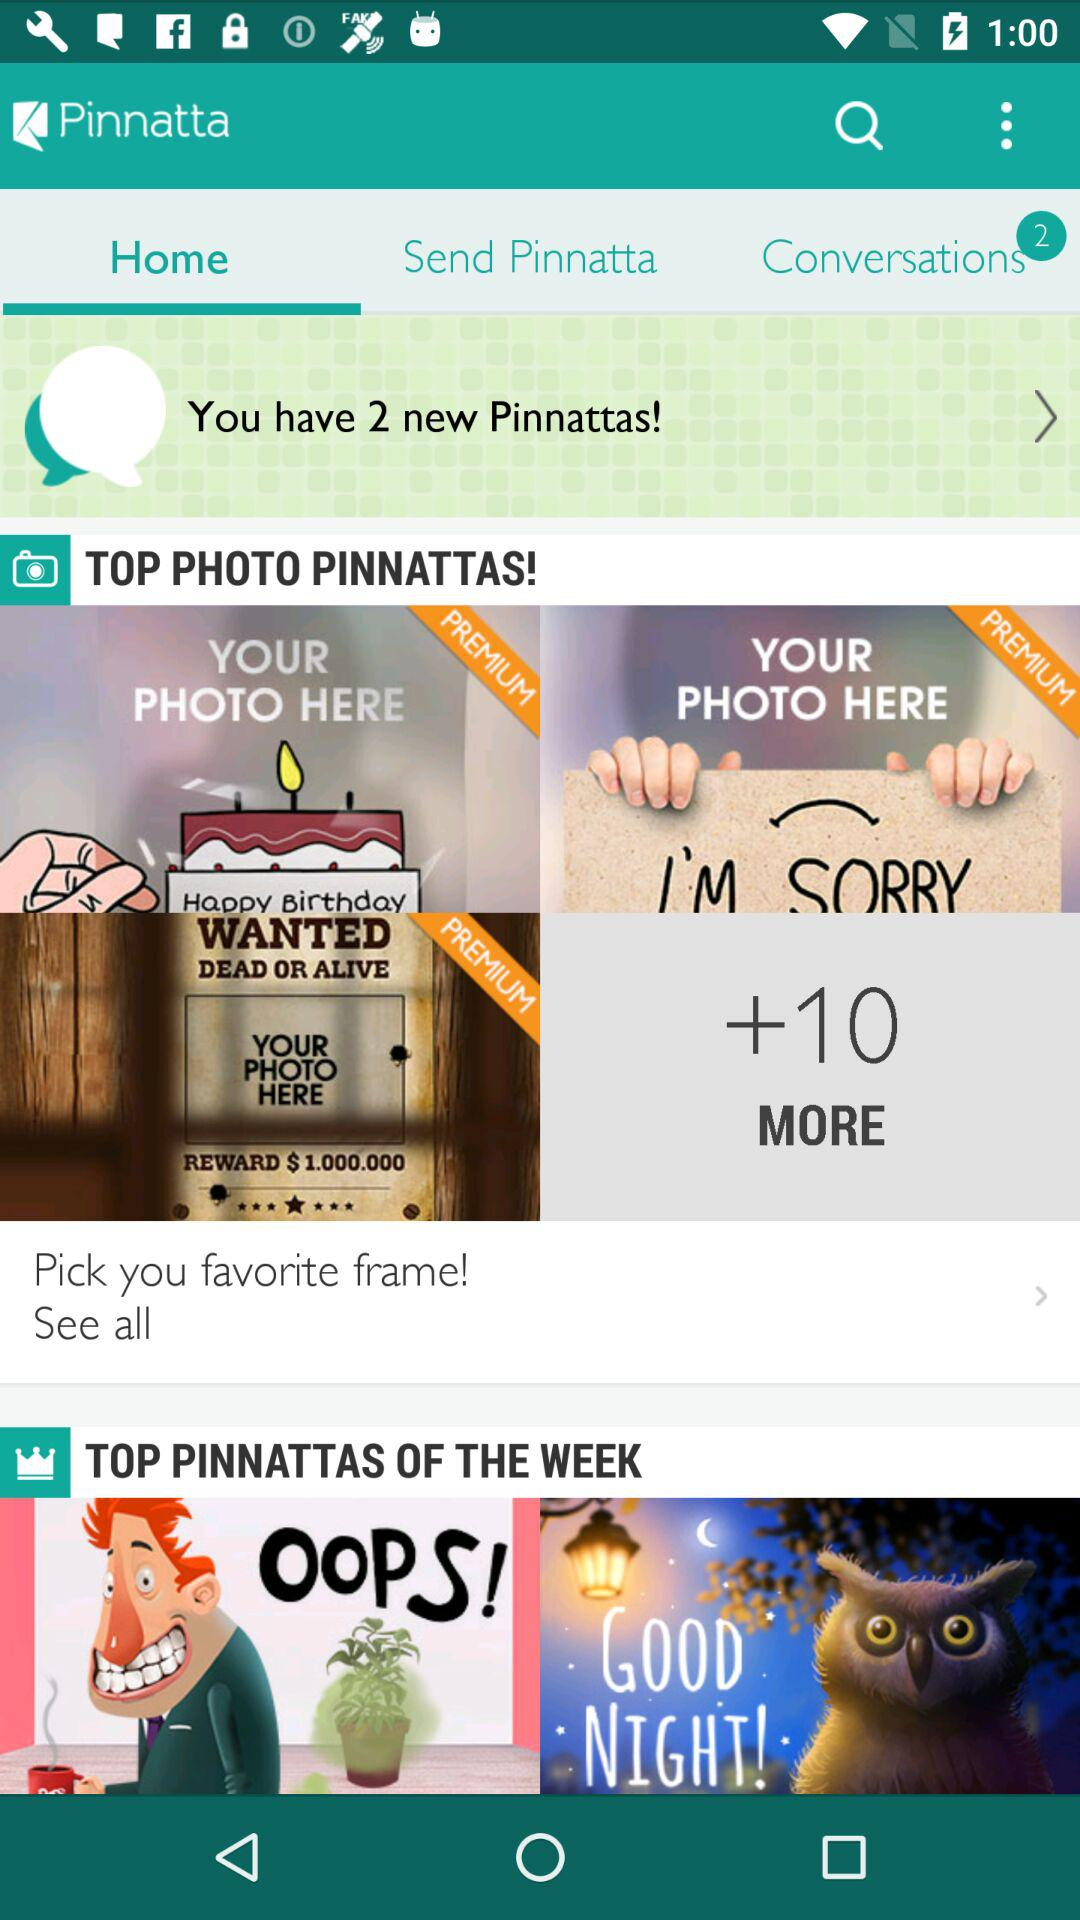How many notifications are there in "Conversations"? There are 2 notifications in "Conversations". 